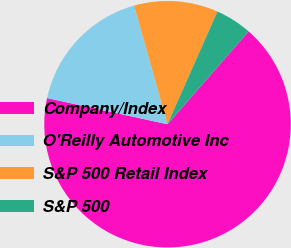Convert chart. <chart><loc_0><loc_0><loc_500><loc_500><pie_chart><fcel>Company/Index<fcel>O'Reilly Automotive Inc<fcel>S&P 500 Retail Index<fcel>S&P 500<nl><fcel>66.98%<fcel>17.23%<fcel>11.01%<fcel>4.79%<nl></chart> 